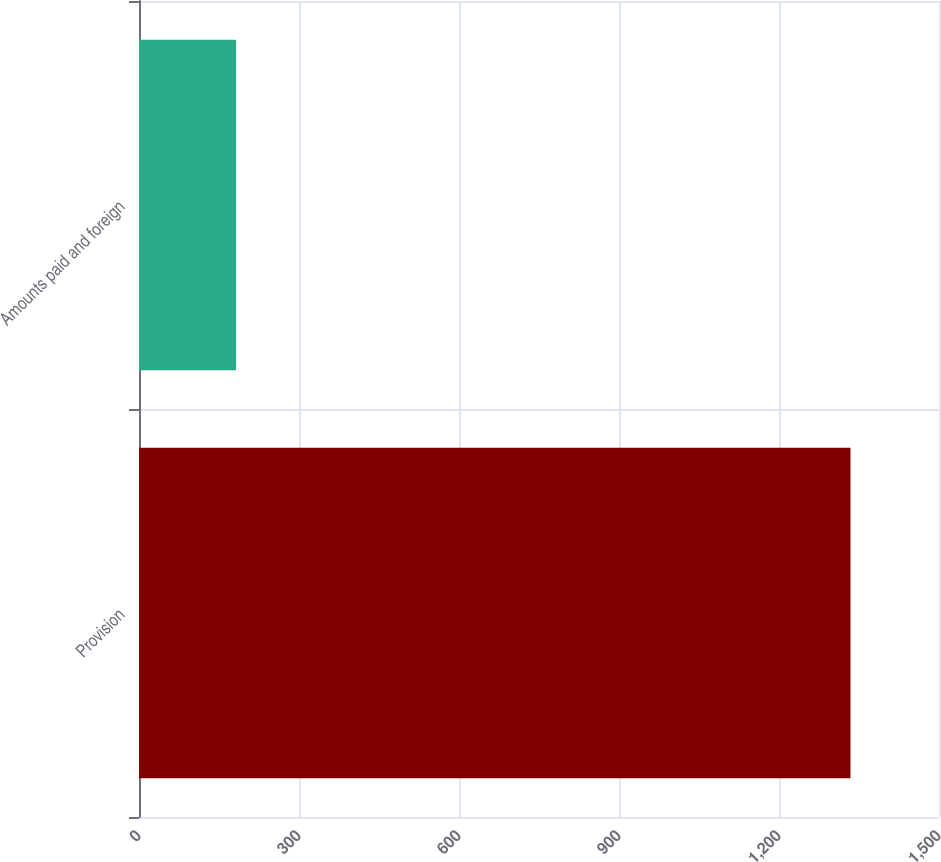<chart> <loc_0><loc_0><loc_500><loc_500><bar_chart><fcel>Provision<fcel>Amounts paid and foreign<nl><fcel>1334<fcel>182<nl></chart> 